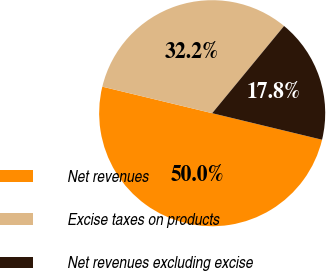Convert chart. <chart><loc_0><loc_0><loc_500><loc_500><pie_chart><fcel>Net revenues<fcel>Excise taxes on products<fcel>Net revenues excluding excise<nl><fcel>50.0%<fcel>32.2%<fcel>17.8%<nl></chart> 